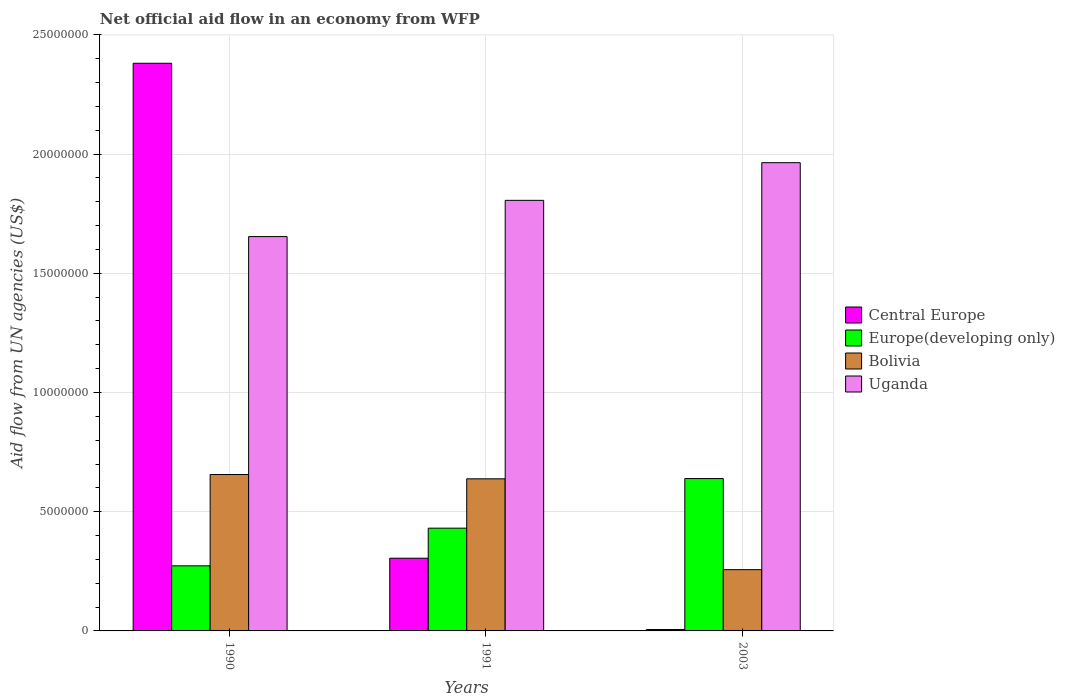How many groups of bars are there?
Give a very brief answer. 3. How many bars are there on the 2nd tick from the left?
Keep it short and to the point. 4. What is the net official aid flow in Uganda in 1990?
Keep it short and to the point. 1.65e+07. Across all years, what is the maximum net official aid flow in Central Europe?
Give a very brief answer. 2.38e+07. Across all years, what is the minimum net official aid flow in Uganda?
Your answer should be very brief. 1.65e+07. In which year was the net official aid flow in Central Europe minimum?
Give a very brief answer. 2003. What is the total net official aid flow in Europe(developing only) in the graph?
Offer a terse response. 1.34e+07. What is the difference between the net official aid flow in Uganda in 1990 and that in 2003?
Your answer should be compact. -3.10e+06. What is the difference between the net official aid flow in Uganda in 1991 and the net official aid flow in Europe(developing only) in 1990?
Offer a terse response. 1.53e+07. What is the average net official aid flow in Europe(developing only) per year?
Make the answer very short. 4.48e+06. In the year 1990, what is the difference between the net official aid flow in Central Europe and net official aid flow in Bolivia?
Provide a short and direct response. 1.72e+07. In how many years, is the net official aid flow in Bolivia greater than 1000000 US$?
Make the answer very short. 3. What is the ratio of the net official aid flow in Uganda in 1990 to that in 2003?
Offer a very short reply. 0.84. What is the difference between the highest and the second highest net official aid flow in Bolivia?
Ensure brevity in your answer.  1.80e+05. What is the difference between the highest and the lowest net official aid flow in Central Europe?
Offer a very short reply. 2.38e+07. In how many years, is the net official aid flow in Bolivia greater than the average net official aid flow in Bolivia taken over all years?
Provide a succinct answer. 2. Is the sum of the net official aid flow in Bolivia in 1990 and 2003 greater than the maximum net official aid flow in Uganda across all years?
Keep it short and to the point. No. Is it the case that in every year, the sum of the net official aid flow in Uganda and net official aid flow in Bolivia is greater than the sum of net official aid flow in Europe(developing only) and net official aid flow in Central Europe?
Provide a short and direct response. Yes. What does the 1st bar from the left in 1991 represents?
Keep it short and to the point. Central Europe. What does the 3rd bar from the right in 1990 represents?
Offer a very short reply. Europe(developing only). Is it the case that in every year, the sum of the net official aid flow in Uganda and net official aid flow in Europe(developing only) is greater than the net official aid flow in Bolivia?
Your answer should be compact. Yes. Are all the bars in the graph horizontal?
Keep it short and to the point. No. How many years are there in the graph?
Your answer should be very brief. 3. Are the values on the major ticks of Y-axis written in scientific E-notation?
Provide a short and direct response. No. Does the graph contain any zero values?
Keep it short and to the point. No. Does the graph contain grids?
Offer a terse response. Yes. Where does the legend appear in the graph?
Offer a terse response. Center right. How are the legend labels stacked?
Your response must be concise. Vertical. What is the title of the graph?
Ensure brevity in your answer.  Net official aid flow in an economy from WFP. Does "Bahrain" appear as one of the legend labels in the graph?
Your answer should be very brief. No. What is the label or title of the Y-axis?
Give a very brief answer. Aid flow from UN agencies (US$). What is the Aid flow from UN agencies (US$) in Central Europe in 1990?
Offer a terse response. 2.38e+07. What is the Aid flow from UN agencies (US$) in Europe(developing only) in 1990?
Give a very brief answer. 2.73e+06. What is the Aid flow from UN agencies (US$) of Bolivia in 1990?
Your answer should be very brief. 6.56e+06. What is the Aid flow from UN agencies (US$) of Uganda in 1990?
Ensure brevity in your answer.  1.65e+07. What is the Aid flow from UN agencies (US$) of Central Europe in 1991?
Offer a very short reply. 3.05e+06. What is the Aid flow from UN agencies (US$) of Europe(developing only) in 1991?
Give a very brief answer. 4.31e+06. What is the Aid flow from UN agencies (US$) in Bolivia in 1991?
Your answer should be very brief. 6.38e+06. What is the Aid flow from UN agencies (US$) of Uganda in 1991?
Keep it short and to the point. 1.81e+07. What is the Aid flow from UN agencies (US$) of Europe(developing only) in 2003?
Offer a terse response. 6.39e+06. What is the Aid flow from UN agencies (US$) in Bolivia in 2003?
Provide a succinct answer. 2.57e+06. What is the Aid flow from UN agencies (US$) in Uganda in 2003?
Offer a very short reply. 1.96e+07. Across all years, what is the maximum Aid flow from UN agencies (US$) in Central Europe?
Make the answer very short. 2.38e+07. Across all years, what is the maximum Aid flow from UN agencies (US$) in Europe(developing only)?
Provide a succinct answer. 6.39e+06. Across all years, what is the maximum Aid flow from UN agencies (US$) in Bolivia?
Your answer should be compact. 6.56e+06. Across all years, what is the maximum Aid flow from UN agencies (US$) of Uganda?
Keep it short and to the point. 1.96e+07. Across all years, what is the minimum Aid flow from UN agencies (US$) in Central Europe?
Provide a short and direct response. 6.00e+04. Across all years, what is the minimum Aid flow from UN agencies (US$) in Europe(developing only)?
Make the answer very short. 2.73e+06. Across all years, what is the minimum Aid flow from UN agencies (US$) of Bolivia?
Provide a succinct answer. 2.57e+06. Across all years, what is the minimum Aid flow from UN agencies (US$) of Uganda?
Your response must be concise. 1.65e+07. What is the total Aid flow from UN agencies (US$) of Central Europe in the graph?
Your response must be concise. 2.69e+07. What is the total Aid flow from UN agencies (US$) of Europe(developing only) in the graph?
Your answer should be very brief. 1.34e+07. What is the total Aid flow from UN agencies (US$) of Bolivia in the graph?
Your answer should be compact. 1.55e+07. What is the total Aid flow from UN agencies (US$) in Uganda in the graph?
Your answer should be very brief. 5.42e+07. What is the difference between the Aid flow from UN agencies (US$) of Central Europe in 1990 and that in 1991?
Your response must be concise. 2.08e+07. What is the difference between the Aid flow from UN agencies (US$) in Europe(developing only) in 1990 and that in 1991?
Ensure brevity in your answer.  -1.58e+06. What is the difference between the Aid flow from UN agencies (US$) of Bolivia in 1990 and that in 1991?
Make the answer very short. 1.80e+05. What is the difference between the Aid flow from UN agencies (US$) in Uganda in 1990 and that in 1991?
Keep it short and to the point. -1.52e+06. What is the difference between the Aid flow from UN agencies (US$) in Central Europe in 1990 and that in 2003?
Your answer should be compact. 2.38e+07. What is the difference between the Aid flow from UN agencies (US$) of Europe(developing only) in 1990 and that in 2003?
Your answer should be very brief. -3.66e+06. What is the difference between the Aid flow from UN agencies (US$) in Bolivia in 1990 and that in 2003?
Provide a succinct answer. 3.99e+06. What is the difference between the Aid flow from UN agencies (US$) in Uganda in 1990 and that in 2003?
Offer a very short reply. -3.10e+06. What is the difference between the Aid flow from UN agencies (US$) of Central Europe in 1991 and that in 2003?
Provide a succinct answer. 2.99e+06. What is the difference between the Aid flow from UN agencies (US$) in Europe(developing only) in 1991 and that in 2003?
Your answer should be very brief. -2.08e+06. What is the difference between the Aid flow from UN agencies (US$) of Bolivia in 1991 and that in 2003?
Offer a very short reply. 3.81e+06. What is the difference between the Aid flow from UN agencies (US$) of Uganda in 1991 and that in 2003?
Keep it short and to the point. -1.58e+06. What is the difference between the Aid flow from UN agencies (US$) of Central Europe in 1990 and the Aid flow from UN agencies (US$) of Europe(developing only) in 1991?
Give a very brief answer. 1.95e+07. What is the difference between the Aid flow from UN agencies (US$) in Central Europe in 1990 and the Aid flow from UN agencies (US$) in Bolivia in 1991?
Make the answer very short. 1.74e+07. What is the difference between the Aid flow from UN agencies (US$) in Central Europe in 1990 and the Aid flow from UN agencies (US$) in Uganda in 1991?
Offer a terse response. 5.75e+06. What is the difference between the Aid flow from UN agencies (US$) in Europe(developing only) in 1990 and the Aid flow from UN agencies (US$) in Bolivia in 1991?
Offer a very short reply. -3.65e+06. What is the difference between the Aid flow from UN agencies (US$) of Europe(developing only) in 1990 and the Aid flow from UN agencies (US$) of Uganda in 1991?
Your answer should be very brief. -1.53e+07. What is the difference between the Aid flow from UN agencies (US$) of Bolivia in 1990 and the Aid flow from UN agencies (US$) of Uganda in 1991?
Give a very brief answer. -1.15e+07. What is the difference between the Aid flow from UN agencies (US$) in Central Europe in 1990 and the Aid flow from UN agencies (US$) in Europe(developing only) in 2003?
Offer a terse response. 1.74e+07. What is the difference between the Aid flow from UN agencies (US$) of Central Europe in 1990 and the Aid flow from UN agencies (US$) of Bolivia in 2003?
Provide a succinct answer. 2.12e+07. What is the difference between the Aid flow from UN agencies (US$) of Central Europe in 1990 and the Aid flow from UN agencies (US$) of Uganda in 2003?
Provide a short and direct response. 4.17e+06. What is the difference between the Aid flow from UN agencies (US$) in Europe(developing only) in 1990 and the Aid flow from UN agencies (US$) in Uganda in 2003?
Provide a succinct answer. -1.69e+07. What is the difference between the Aid flow from UN agencies (US$) in Bolivia in 1990 and the Aid flow from UN agencies (US$) in Uganda in 2003?
Keep it short and to the point. -1.31e+07. What is the difference between the Aid flow from UN agencies (US$) in Central Europe in 1991 and the Aid flow from UN agencies (US$) in Europe(developing only) in 2003?
Keep it short and to the point. -3.34e+06. What is the difference between the Aid flow from UN agencies (US$) of Central Europe in 1991 and the Aid flow from UN agencies (US$) of Bolivia in 2003?
Ensure brevity in your answer.  4.80e+05. What is the difference between the Aid flow from UN agencies (US$) in Central Europe in 1991 and the Aid flow from UN agencies (US$) in Uganda in 2003?
Your answer should be very brief. -1.66e+07. What is the difference between the Aid flow from UN agencies (US$) of Europe(developing only) in 1991 and the Aid flow from UN agencies (US$) of Bolivia in 2003?
Offer a terse response. 1.74e+06. What is the difference between the Aid flow from UN agencies (US$) of Europe(developing only) in 1991 and the Aid flow from UN agencies (US$) of Uganda in 2003?
Provide a succinct answer. -1.53e+07. What is the difference between the Aid flow from UN agencies (US$) of Bolivia in 1991 and the Aid flow from UN agencies (US$) of Uganda in 2003?
Offer a very short reply. -1.33e+07. What is the average Aid flow from UN agencies (US$) of Central Europe per year?
Your answer should be very brief. 8.97e+06. What is the average Aid flow from UN agencies (US$) in Europe(developing only) per year?
Your answer should be compact. 4.48e+06. What is the average Aid flow from UN agencies (US$) in Bolivia per year?
Keep it short and to the point. 5.17e+06. What is the average Aid flow from UN agencies (US$) in Uganda per year?
Provide a succinct answer. 1.81e+07. In the year 1990, what is the difference between the Aid flow from UN agencies (US$) of Central Europe and Aid flow from UN agencies (US$) of Europe(developing only)?
Provide a succinct answer. 2.11e+07. In the year 1990, what is the difference between the Aid flow from UN agencies (US$) in Central Europe and Aid flow from UN agencies (US$) in Bolivia?
Your answer should be very brief. 1.72e+07. In the year 1990, what is the difference between the Aid flow from UN agencies (US$) in Central Europe and Aid flow from UN agencies (US$) in Uganda?
Offer a terse response. 7.27e+06. In the year 1990, what is the difference between the Aid flow from UN agencies (US$) of Europe(developing only) and Aid flow from UN agencies (US$) of Bolivia?
Your response must be concise. -3.83e+06. In the year 1990, what is the difference between the Aid flow from UN agencies (US$) in Europe(developing only) and Aid flow from UN agencies (US$) in Uganda?
Provide a short and direct response. -1.38e+07. In the year 1990, what is the difference between the Aid flow from UN agencies (US$) in Bolivia and Aid flow from UN agencies (US$) in Uganda?
Offer a very short reply. -9.98e+06. In the year 1991, what is the difference between the Aid flow from UN agencies (US$) of Central Europe and Aid flow from UN agencies (US$) of Europe(developing only)?
Offer a terse response. -1.26e+06. In the year 1991, what is the difference between the Aid flow from UN agencies (US$) in Central Europe and Aid flow from UN agencies (US$) in Bolivia?
Your response must be concise. -3.33e+06. In the year 1991, what is the difference between the Aid flow from UN agencies (US$) of Central Europe and Aid flow from UN agencies (US$) of Uganda?
Provide a short and direct response. -1.50e+07. In the year 1991, what is the difference between the Aid flow from UN agencies (US$) of Europe(developing only) and Aid flow from UN agencies (US$) of Bolivia?
Make the answer very short. -2.07e+06. In the year 1991, what is the difference between the Aid flow from UN agencies (US$) of Europe(developing only) and Aid flow from UN agencies (US$) of Uganda?
Offer a terse response. -1.38e+07. In the year 1991, what is the difference between the Aid flow from UN agencies (US$) of Bolivia and Aid flow from UN agencies (US$) of Uganda?
Your answer should be compact. -1.17e+07. In the year 2003, what is the difference between the Aid flow from UN agencies (US$) of Central Europe and Aid flow from UN agencies (US$) of Europe(developing only)?
Make the answer very short. -6.33e+06. In the year 2003, what is the difference between the Aid flow from UN agencies (US$) of Central Europe and Aid flow from UN agencies (US$) of Bolivia?
Offer a very short reply. -2.51e+06. In the year 2003, what is the difference between the Aid flow from UN agencies (US$) in Central Europe and Aid flow from UN agencies (US$) in Uganda?
Offer a terse response. -1.96e+07. In the year 2003, what is the difference between the Aid flow from UN agencies (US$) in Europe(developing only) and Aid flow from UN agencies (US$) in Bolivia?
Give a very brief answer. 3.82e+06. In the year 2003, what is the difference between the Aid flow from UN agencies (US$) in Europe(developing only) and Aid flow from UN agencies (US$) in Uganda?
Your response must be concise. -1.32e+07. In the year 2003, what is the difference between the Aid flow from UN agencies (US$) in Bolivia and Aid flow from UN agencies (US$) in Uganda?
Provide a short and direct response. -1.71e+07. What is the ratio of the Aid flow from UN agencies (US$) in Central Europe in 1990 to that in 1991?
Offer a very short reply. 7.81. What is the ratio of the Aid flow from UN agencies (US$) of Europe(developing only) in 1990 to that in 1991?
Offer a very short reply. 0.63. What is the ratio of the Aid flow from UN agencies (US$) of Bolivia in 1990 to that in 1991?
Provide a short and direct response. 1.03. What is the ratio of the Aid flow from UN agencies (US$) of Uganda in 1990 to that in 1991?
Provide a succinct answer. 0.92. What is the ratio of the Aid flow from UN agencies (US$) of Central Europe in 1990 to that in 2003?
Provide a short and direct response. 396.83. What is the ratio of the Aid flow from UN agencies (US$) in Europe(developing only) in 1990 to that in 2003?
Offer a very short reply. 0.43. What is the ratio of the Aid flow from UN agencies (US$) of Bolivia in 1990 to that in 2003?
Give a very brief answer. 2.55. What is the ratio of the Aid flow from UN agencies (US$) of Uganda in 1990 to that in 2003?
Keep it short and to the point. 0.84. What is the ratio of the Aid flow from UN agencies (US$) of Central Europe in 1991 to that in 2003?
Your response must be concise. 50.83. What is the ratio of the Aid flow from UN agencies (US$) in Europe(developing only) in 1991 to that in 2003?
Your answer should be compact. 0.67. What is the ratio of the Aid flow from UN agencies (US$) of Bolivia in 1991 to that in 2003?
Your answer should be very brief. 2.48. What is the ratio of the Aid flow from UN agencies (US$) in Uganda in 1991 to that in 2003?
Your answer should be very brief. 0.92. What is the difference between the highest and the second highest Aid flow from UN agencies (US$) of Central Europe?
Offer a very short reply. 2.08e+07. What is the difference between the highest and the second highest Aid flow from UN agencies (US$) of Europe(developing only)?
Your answer should be very brief. 2.08e+06. What is the difference between the highest and the second highest Aid flow from UN agencies (US$) in Uganda?
Offer a very short reply. 1.58e+06. What is the difference between the highest and the lowest Aid flow from UN agencies (US$) in Central Europe?
Your response must be concise. 2.38e+07. What is the difference between the highest and the lowest Aid flow from UN agencies (US$) of Europe(developing only)?
Provide a succinct answer. 3.66e+06. What is the difference between the highest and the lowest Aid flow from UN agencies (US$) in Bolivia?
Provide a succinct answer. 3.99e+06. What is the difference between the highest and the lowest Aid flow from UN agencies (US$) of Uganda?
Give a very brief answer. 3.10e+06. 